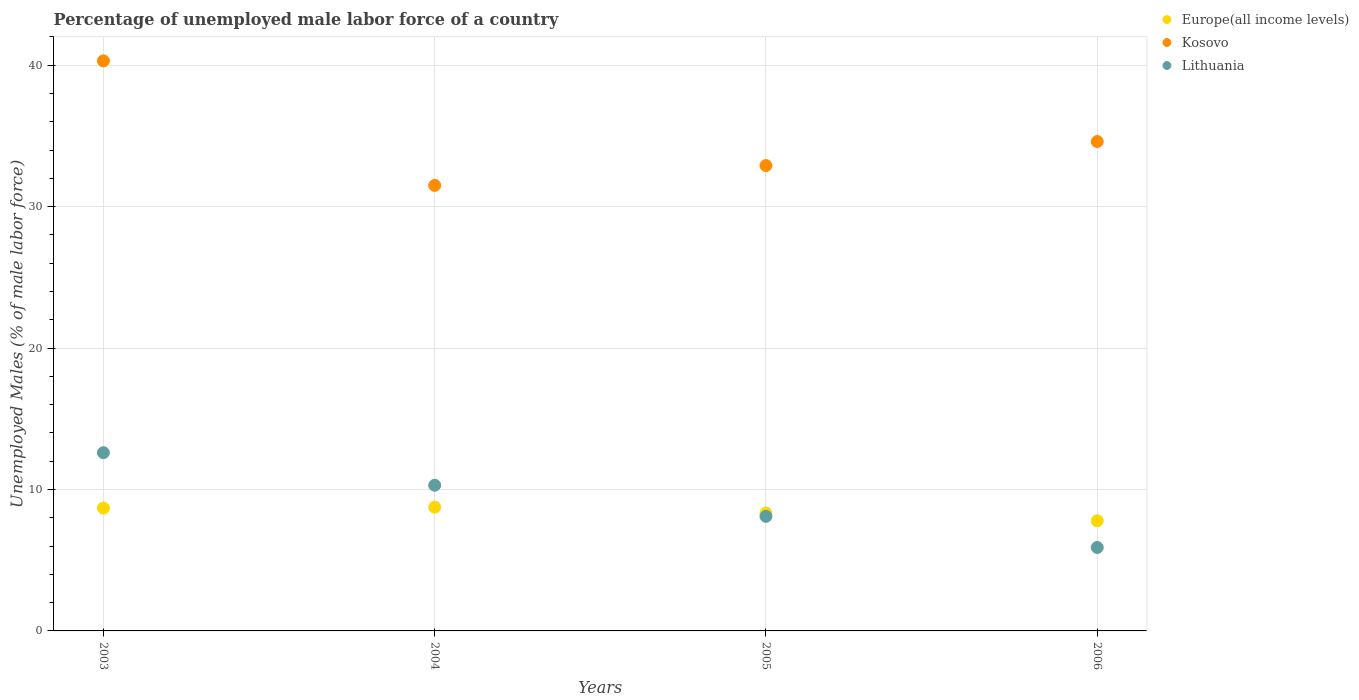How many different coloured dotlines are there?
Ensure brevity in your answer.  3. Is the number of dotlines equal to the number of legend labels?
Make the answer very short. Yes. What is the percentage of unemployed male labor force in Lithuania in 2004?
Your response must be concise. 10.3. Across all years, what is the maximum percentage of unemployed male labor force in Lithuania?
Your response must be concise. 12.6. Across all years, what is the minimum percentage of unemployed male labor force in Europe(all income levels)?
Offer a very short reply. 7.79. In which year was the percentage of unemployed male labor force in Kosovo maximum?
Keep it short and to the point. 2003. In which year was the percentage of unemployed male labor force in Europe(all income levels) minimum?
Offer a very short reply. 2006. What is the total percentage of unemployed male labor force in Lithuania in the graph?
Make the answer very short. 36.9. What is the difference between the percentage of unemployed male labor force in Lithuania in 2003 and that in 2006?
Provide a short and direct response. 6.7. What is the difference between the percentage of unemployed male labor force in Europe(all income levels) in 2004 and the percentage of unemployed male labor force in Kosovo in 2005?
Your answer should be compact. -24.15. What is the average percentage of unemployed male labor force in Kosovo per year?
Offer a very short reply. 34.82. In the year 2005, what is the difference between the percentage of unemployed male labor force in Lithuania and percentage of unemployed male labor force in Europe(all income levels)?
Keep it short and to the point. -0.23. In how many years, is the percentage of unemployed male labor force in Kosovo greater than 34 %?
Provide a short and direct response. 2. What is the ratio of the percentage of unemployed male labor force in Europe(all income levels) in 2003 to that in 2005?
Offer a very short reply. 1.04. Is the percentage of unemployed male labor force in Europe(all income levels) in 2005 less than that in 2006?
Provide a succinct answer. No. Is the difference between the percentage of unemployed male labor force in Lithuania in 2003 and 2004 greater than the difference between the percentage of unemployed male labor force in Europe(all income levels) in 2003 and 2004?
Make the answer very short. Yes. What is the difference between the highest and the second highest percentage of unemployed male labor force in Europe(all income levels)?
Offer a terse response. 0.07. What is the difference between the highest and the lowest percentage of unemployed male labor force in Lithuania?
Make the answer very short. 6.7. In how many years, is the percentage of unemployed male labor force in Europe(all income levels) greater than the average percentage of unemployed male labor force in Europe(all income levels) taken over all years?
Ensure brevity in your answer.  2. Is the sum of the percentage of unemployed male labor force in Europe(all income levels) in 2004 and 2005 greater than the maximum percentage of unemployed male labor force in Kosovo across all years?
Offer a terse response. No. Is the percentage of unemployed male labor force in Kosovo strictly greater than the percentage of unemployed male labor force in Europe(all income levels) over the years?
Keep it short and to the point. Yes. What is the difference between two consecutive major ticks on the Y-axis?
Your answer should be very brief. 10. Are the values on the major ticks of Y-axis written in scientific E-notation?
Your answer should be compact. No. Where does the legend appear in the graph?
Offer a terse response. Top right. What is the title of the graph?
Your answer should be very brief. Percentage of unemployed male labor force of a country. Does "Dominican Republic" appear as one of the legend labels in the graph?
Provide a short and direct response. No. What is the label or title of the X-axis?
Offer a very short reply. Years. What is the label or title of the Y-axis?
Offer a very short reply. Unemployed Males (% of male labor force). What is the Unemployed Males (% of male labor force) of Europe(all income levels) in 2003?
Offer a very short reply. 8.68. What is the Unemployed Males (% of male labor force) in Kosovo in 2003?
Your answer should be very brief. 40.3. What is the Unemployed Males (% of male labor force) in Lithuania in 2003?
Your answer should be compact. 12.6. What is the Unemployed Males (% of male labor force) in Europe(all income levels) in 2004?
Provide a short and direct response. 8.75. What is the Unemployed Males (% of male labor force) of Kosovo in 2004?
Make the answer very short. 31.5. What is the Unemployed Males (% of male labor force) in Lithuania in 2004?
Ensure brevity in your answer.  10.3. What is the Unemployed Males (% of male labor force) of Europe(all income levels) in 2005?
Your response must be concise. 8.33. What is the Unemployed Males (% of male labor force) in Kosovo in 2005?
Keep it short and to the point. 32.9. What is the Unemployed Males (% of male labor force) of Lithuania in 2005?
Make the answer very short. 8.1. What is the Unemployed Males (% of male labor force) in Europe(all income levels) in 2006?
Your answer should be compact. 7.79. What is the Unemployed Males (% of male labor force) of Kosovo in 2006?
Make the answer very short. 34.6. What is the Unemployed Males (% of male labor force) in Lithuania in 2006?
Your answer should be compact. 5.9. Across all years, what is the maximum Unemployed Males (% of male labor force) in Europe(all income levels)?
Offer a terse response. 8.75. Across all years, what is the maximum Unemployed Males (% of male labor force) in Kosovo?
Your response must be concise. 40.3. Across all years, what is the maximum Unemployed Males (% of male labor force) in Lithuania?
Your answer should be very brief. 12.6. Across all years, what is the minimum Unemployed Males (% of male labor force) of Europe(all income levels)?
Make the answer very short. 7.79. Across all years, what is the minimum Unemployed Males (% of male labor force) in Kosovo?
Your answer should be very brief. 31.5. Across all years, what is the minimum Unemployed Males (% of male labor force) in Lithuania?
Provide a succinct answer. 5.9. What is the total Unemployed Males (% of male labor force) in Europe(all income levels) in the graph?
Your answer should be very brief. 33.55. What is the total Unemployed Males (% of male labor force) in Kosovo in the graph?
Keep it short and to the point. 139.3. What is the total Unemployed Males (% of male labor force) of Lithuania in the graph?
Offer a very short reply. 36.9. What is the difference between the Unemployed Males (% of male labor force) of Europe(all income levels) in 2003 and that in 2004?
Ensure brevity in your answer.  -0.07. What is the difference between the Unemployed Males (% of male labor force) of Kosovo in 2003 and that in 2004?
Provide a short and direct response. 8.8. What is the difference between the Unemployed Males (% of male labor force) of Lithuania in 2003 and that in 2004?
Provide a succinct answer. 2.3. What is the difference between the Unemployed Males (% of male labor force) of Europe(all income levels) in 2003 and that in 2005?
Your answer should be compact. 0.35. What is the difference between the Unemployed Males (% of male labor force) in Kosovo in 2003 and that in 2005?
Your answer should be very brief. 7.4. What is the difference between the Unemployed Males (% of male labor force) in Europe(all income levels) in 2003 and that in 2006?
Your response must be concise. 0.9. What is the difference between the Unemployed Males (% of male labor force) in Kosovo in 2003 and that in 2006?
Make the answer very short. 5.7. What is the difference between the Unemployed Males (% of male labor force) in Europe(all income levels) in 2004 and that in 2005?
Offer a very short reply. 0.41. What is the difference between the Unemployed Males (% of male labor force) of Kosovo in 2004 and that in 2005?
Your response must be concise. -1.4. What is the difference between the Unemployed Males (% of male labor force) of Lithuania in 2004 and that in 2005?
Provide a short and direct response. 2.2. What is the difference between the Unemployed Males (% of male labor force) in Europe(all income levels) in 2004 and that in 2006?
Your answer should be very brief. 0.96. What is the difference between the Unemployed Males (% of male labor force) of Europe(all income levels) in 2005 and that in 2006?
Make the answer very short. 0.55. What is the difference between the Unemployed Males (% of male labor force) of Kosovo in 2005 and that in 2006?
Offer a terse response. -1.7. What is the difference between the Unemployed Males (% of male labor force) in Lithuania in 2005 and that in 2006?
Keep it short and to the point. 2.2. What is the difference between the Unemployed Males (% of male labor force) of Europe(all income levels) in 2003 and the Unemployed Males (% of male labor force) of Kosovo in 2004?
Offer a very short reply. -22.82. What is the difference between the Unemployed Males (% of male labor force) in Europe(all income levels) in 2003 and the Unemployed Males (% of male labor force) in Lithuania in 2004?
Your answer should be very brief. -1.62. What is the difference between the Unemployed Males (% of male labor force) in Kosovo in 2003 and the Unemployed Males (% of male labor force) in Lithuania in 2004?
Give a very brief answer. 30. What is the difference between the Unemployed Males (% of male labor force) in Europe(all income levels) in 2003 and the Unemployed Males (% of male labor force) in Kosovo in 2005?
Your answer should be compact. -24.22. What is the difference between the Unemployed Males (% of male labor force) of Europe(all income levels) in 2003 and the Unemployed Males (% of male labor force) of Lithuania in 2005?
Make the answer very short. 0.58. What is the difference between the Unemployed Males (% of male labor force) of Kosovo in 2003 and the Unemployed Males (% of male labor force) of Lithuania in 2005?
Make the answer very short. 32.2. What is the difference between the Unemployed Males (% of male labor force) of Europe(all income levels) in 2003 and the Unemployed Males (% of male labor force) of Kosovo in 2006?
Provide a short and direct response. -25.92. What is the difference between the Unemployed Males (% of male labor force) in Europe(all income levels) in 2003 and the Unemployed Males (% of male labor force) in Lithuania in 2006?
Give a very brief answer. 2.78. What is the difference between the Unemployed Males (% of male labor force) in Kosovo in 2003 and the Unemployed Males (% of male labor force) in Lithuania in 2006?
Your response must be concise. 34.4. What is the difference between the Unemployed Males (% of male labor force) of Europe(all income levels) in 2004 and the Unemployed Males (% of male labor force) of Kosovo in 2005?
Your response must be concise. -24.15. What is the difference between the Unemployed Males (% of male labor force) of Europe(all income levels) in 2004 and the Unemployed Males (% of male labor force) of Lithuania in 2005?
Provide a succinct answer. 0.65. What is the difference between the Unemployed Males (% of male labor force) of Kosovo in 2004 and the Unemployed Males (% of male labor force) of Lithuania in 2005?
Your answer should be compact. 23.4. What is the difference between the Unemployed Males (% of male labor force) in Europe(all income levels) in 2004 and the Unemployed Males (% of male labor force) in Kosovo in 2006?
Ensure brevity in your answer.  -25.85. What is the difference between the Unemployed Males (% of male labor force) in Europe(all income levels) in 2004 and the Unemployed Males (% of male labor force) in Lithuania in 2006?
Ensure brevity in your answer.  2.85. What is the difference between the Unemployed Males (% of male labor force) of Kosovo in 2004 and the Unemployed Males (% of male labor force) of Lithuania in 2006?
Provide a succinct answer. 25.6. What is the difference between the Unemployed Males (% of male labor force) in Europe(all income levels) in 2005 and the Unemployed Males (% of male labor force) in Kosovo in 2006?
Make the answer very short. -26.27. What is the difference between the Unemployed Males (% of male labor force) in Europe(all income levels) in 2005 and the Unemployed Males (% of male labor force) in Lithuania in 2006?
Give a very brief answer. 2.43. What is the difference between the Unemployed Males (% of male labor force) in Kosovo in 2005 and the Unemployed Males (% of male labor force) in Lithuania in 2006?
Your response must be concise. 27. What is the average Unemployed Males (% of male labor force) in Europe(all income levels) per year?
Make the answer very short. 8.39. What is the average Unemployed Males (% of male labor force) of Kosovo per year?
Offer a very short reply. 34.83. What is the average Unemployed Males (% of male labor force) of Lithuania per year?
Provide a short and direct response. 9.22. In the year 2003, what is the difference between the Unemployed Males (% of male labor force) in Europe(all income levels) and Unemployed Males (% of male labor force) in Kosovo?
Your answer should be very brief. -31.62. In the year 2003, what is the difference between the Unemployed Males (% of male labor force) in Europe(all income levels) and Unemployed Males (% of male labor force) in Lithuania?
Give a very brief answer. -3.92. In the year 2003, what is the difference between the Unemployed Males (% of male labor force) of Kosovo and Unemployed Males (% of male labor force) of Lithuania?
Your answer should be compact. 27.7. In the year 2004, what is the difference between the Unemployed Males (% of male labor force) in Europe(all income levels) and Unemployed Males (% of male labor force) in Kosovo?
Provide a short and direct response. -22.75. In the year 2004, what is the difference between the Unemployed Males (% of male labor force) of Europe(all income levels) and Unemployed Males (% of male labor force) of Lithuania?
Make the answer very short. -1.55. In the year 2004, what is the difference between the Unemployed Males (% of male labor force) of Kosovo and Unemployed Males (% of male labor force) of Lithuania?
Your answer should be very brief. 21.2. In the year 2005, what is the difference between the Unemployed Males (% of male labor force) of Europe(all income levels) and Unemployed Males (% of male labor force) of Kosovo?
Offer a very short reply. -24.57. In the year 2005, what is the difference between the Unemployed Males (% of male labor force) in Europe(all income levels) and Unemployed Males (% of male labor force) in Lithuania?
Give a very brief answer. 0.23. In the year 2005, what is the difference between the Unemployed Males (% of male labor force) of Kosovo and Unemployed Males (% of male labor force) of Lithuania?
Your answer should be very brief. 24.8. In the year 2006, what is the difference between the Unemployed Males (% of male labor force) in Europe(all income levels) and Unemployed Males (% of male labor force) in Kosovo?
Provide a short and direct response. -26.81. In the year 2006, what is the difference between the Unemployed Males (% of male labor force) in Europe(all income levels) and Unemployed Males (% of male labor force) in Lithuania?
Provide a short and direct response. 1.89. In the year 2006, what is the difference between the Unemployed Males (% of male labor force) of Kosovo and Unemployed Males (% of male labor force) of Lithuania?
Your answer should be very brief. 28.7. What is the ratio of the Unemployed Males (% of male labor force) of Kosovo in 2003 to that in 2004?
Provide a short and direct response. 1.28. What is the ratio of the Unemployed Males (% of male labor force) of Lithuania in 2003 to that in 2004?
Make the answer very short. 1.22. What is the ratio of the Unemployed Males (% of male labor force) in Europe(all income levels) in 2003 to that in 2005?
Ensure brevity in your answer.  1.04. What is the ratio of the Unemployed Males (% of male labor force) of Kosovo in 2003 to that in 2005?
Your response must be concise. 1.22. What is the ratio of the Unemployed Males (% of male labor force) in Lithuania in 2003 to that in 2005?
Provide a succinct answer. 1.56. What is the ratio of the Unemployed Males (% of male labor force) of Europe(all income levels) in 2003 to that in 2006?
Provide a short and direct response. 1.12. What is the ratio of the Unemployed Males (% of male labor force) of Kosovo in 2003 to that in 2006?
Make the answer very short. 1.16. What is the ratio of the Unemployed Males (% of male labor force) of Lithuania in 2003 to that in 2006?
Provide a succinct answer. 2.14. What is the ratio of the Unemployed Males (% of male labor force) in Europe(all income levels) in 2004 to that in 2005?
Offer a very short reply. 1.05. What is the ratio of the Unemployed Males (% of male labor force) in Kosovo in 2004 to that in 2005?
Offer a terse response. 0.96. What is the ratio of the Unemployed Males (% of male labor force) of Lithuania in 2004 to that in 2005?
Give a very brief answer. 1.27. What is the ratio of the Unemployed Males (% of male labor force) in Europe(all income levels) in 2004 to that in 2006?
Keep it short and to the point. 1.12. What is the ratio of the Unemployed Males (% of male labor force) in Kosovo in 2004 to that in 2006?
Your answer should be very brief. 0.91. What is the ratio of the Unemployed Males (% of male labor force) of Lithuania in 2004 to that in 2006?
Your response must be concise. 1.75. What is the ratio of the Unemployed Males (% of male labor force) in Europe(all income levels) in 2005 to that in 2006?
Provide a short and direct response. 1.07. What is the ratio of the Unemployed Males (% of male labor force) of Kosovo in 2005 to that in 2006?
Give a very brief answer. 0.95. What is the ratio of the Unemployed Males (% of male labor force) in Lithuania in 2005 to that in 2006?
Your response must be concise. 1.37. What is the difference between the highest and the second highest Unemployed Males (% of male labor force) of Europe(all income levels)?
Your response must be concise. 0.07. What is the difference between the highest and the second highest Unemployed Males (% of male labor force) in Lithuania?
Provide a succinct answer. 2.3. What is the difference between the highest and the lowest Unemployed Males (% of male labor force) in Europe(all income levels)?
Your response must be concise. 0.96. What is the difference between the highest and the lowest Unemployed Males (% of male labor force) in Kosovo?
Give a very brief answer. 8.8. What is the difference between the highest and the lowest Unemployed Males (% of male labor force) of Lithuania?
Your answer should be compact. 6.7. 